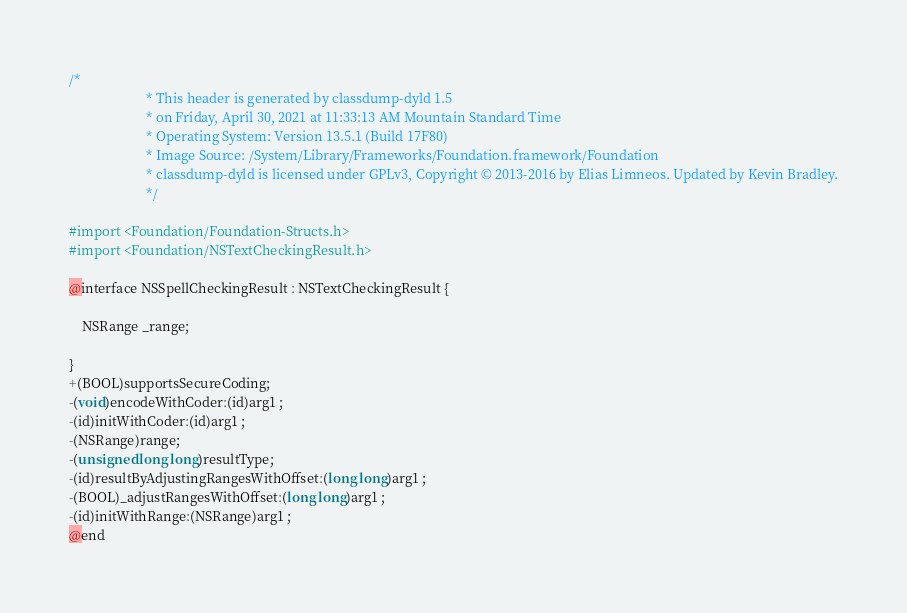<code> <loc_0><loc_0><loc_500><loc_500><_C_>/*
                       * This header is generated by classdump-dyld 1.5
                       * on Friday, April 30, 2021 at 11:33:13 AM Mountain Standard Time
                       * Operating System: Version 13.5.1 (Build 17F80)
                       * Image Source: /System/Library/Frameworks/Foundation.framework/Foundation
                       * classdump-dyld is licensed under GPLv3, Copyright © 2013-2016 by Elias Limneos. Updated by Kevin Bradley.
                       */

#import <Foundation/Foundation-Structs.h>
#import <Foundation/NSTextCheckingResult.h>

@interface NSSpellCheckingResult : NSTextCheckingResult {

	NSRange _range;

}
+(BOOL)supportsSecureCoding;
-(void)encodeWithCoder:(id)arg1 ;
-(id)initWithCoder:(id)arg1 ;
-(NSRange)range;
-(unsigned long long)resultType;
-(id)resultByAdjustingRangesWithOffset:(long long)arg1 ;
-(BOOL)_adjustRangesWithOffset:(long long)arg1 ;
-(id)initWithRange:(NSRange)arg1 ;
@end

</code> 